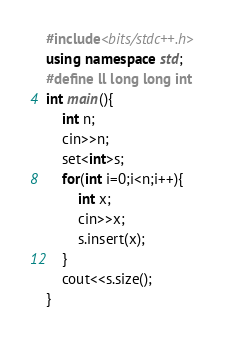Convert code to text. <code><loc_0><loc_0><loc_500><loc_500><_C++_>#include<bits/stdc++.h>
using namespace std;
#define ll long long int
int main(){
    int n;
    cin>>n;
    set<int>s;
    for(int i=0;i<n;i++){
        int x;
        cin>>x;
        s.insert(x);
    }
    cout<<s.size();
}</code> 